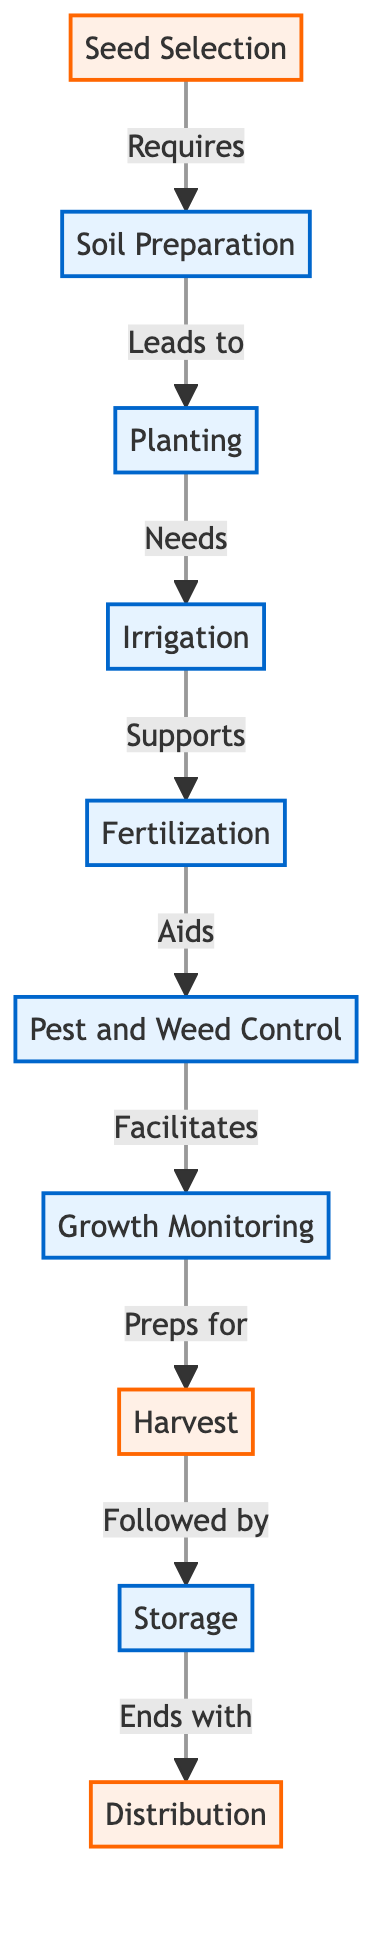What is the first stage in the crop production cycle? The diagram starts with the node "Seed Selection," indicating that it is the first stage in the crop production cycle.
Answer: Seed Selection How many processes are listed in the crop production cycle? The processes in the diagram are Soil Preparation, Planting, Irrigation, Fertilization, Pest and Weed Control, Growth Monitoring, and Storage, making a total of seven processes listed.
Answer: 7 What stage is followed by Harvest? The "Harvest" stage is preceded by "Growth Monitoring," as indicated by the directed flow from Growth Monitoring to Harvest in the diagram.
Answer: Growth Monitoring Which stage directly leads to Storage? The stage "Harvest" directly leads to "Storage," according to the flow between these two nodes in the diagram.
Answer: Harvest What aids Fertilization in the crop production cycle? "Pest and Weed Control" aids Fertilization according to the relationship shown in the diagram where Fertilization is linked to Pest and Weed Control.
Answer: Pest and Weed Control What is the last stage in the crop production cycle? The diagram indicates the last stage in the crop production cycle is "Distribution," which follows the "Storage" stage.
Answer: Distribution How does Soil Preparation relate to Seed Selection? "Soil Preparation" is dependent on "Seed Selection," as indicated by the directed edge in the diagram showing that Seed Selection requires the process of Soil Preparation before it can happen.
Answer: Requires Which stage comes after Irrigation? In the diagram, "Fertilization" comes directly after "Irrigation," establishing a clear connection between these two stages in the crop production cycle.
Answer: Fertilization What is the role of Growth Monitoring in the process? "Growth Monitoring" prepares the production for the "Harvest" stage, indicating its role in ensuring crops are ready for harvesting.
Answer: Preps for 